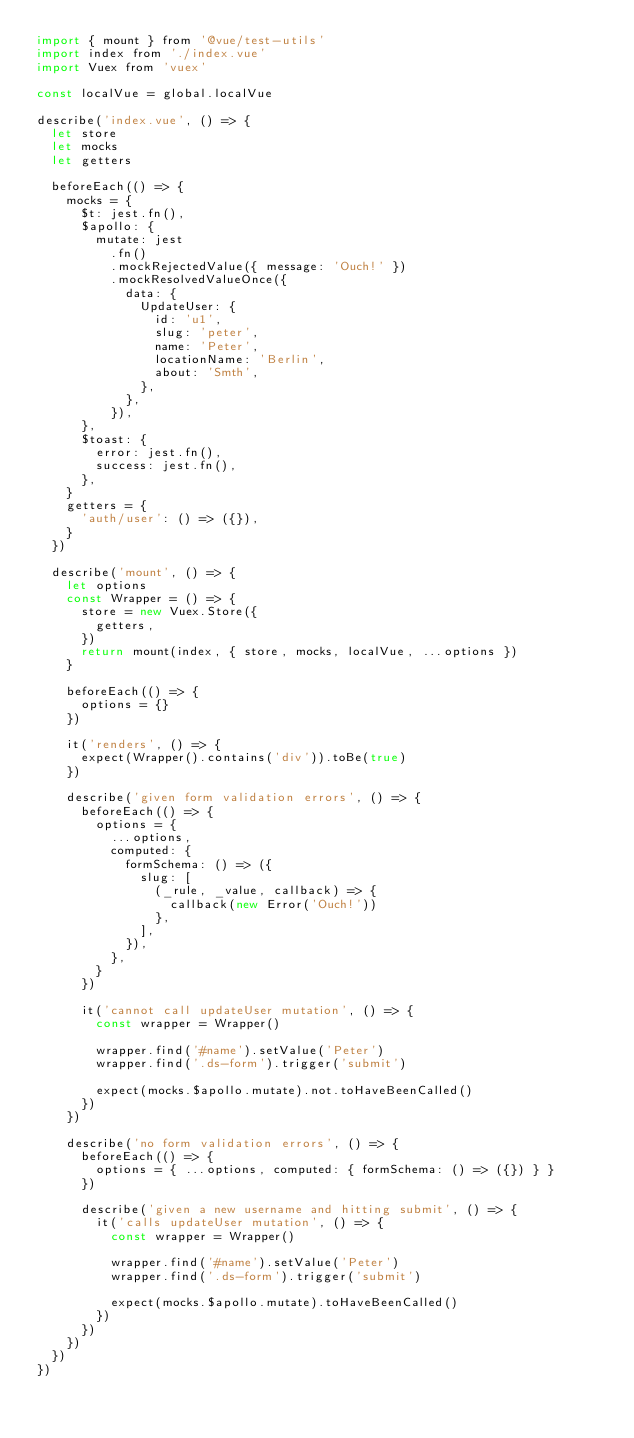<code> <loc_0><loc_0><loc_500><loc_500><_JavaScript_>import { mount } from '@vue/test-utils'
import index from './index.vue'
import Vuex from 'vuex'

const localVue = global.localVue

describe('index.vue', () => {
  let store
  let mocks
  let getters

  beforeEach(() => {
    mocks = {
      $t: jest.fn(),
      $apollo: {
        mutate: jest
          .fn()
          .mockRejectedValue({ message: 'Ouch!' })
          .mockResolvedValueOnce({
            data: {
              UpdateUser: {
                id: 'u1',
                slug: 'peter',
                name: 'Peter',
                locationName: 'Berlin',
                about: 'Smth',
              },
            },
          }),
      },
      $toast: {
        error: jest.fn(),
        success: jest.fn(),
      },
    }
    getters = {
      'auth/user': () => ({}),
    }
  })

  describe('mount', () => {
    let options
    const Wrapper = () => {
      store = new Vuex.Store({
        getters,
      })
      return mount(index, { store, mocks, localVue, ...options })
    }

    beforeEach(() => {
      options = {}
    })

    it('renders', () => {
      expect(Wrapper().contains('div')).toBe(true)
    })

    describe('given form validation errors', () => {
      beforeEach(() => {
        options = {
          ...options,
          computed: {
            formSchema: () => ({
              slug: [
                (_rule, _value, callback) => {
                  callback(new Error('Ouch!'))
                },
              ],
            }),
          },
        }
      })

      it('cannot call updateUser mutation', () => {
        const wrapper = Wrapper()

        wrapper.find('#name').setValue('Peter')
        wrapper.find('.ds-form').trigger('submit')

        expect(mocks.$apollo.mutate).not.toHaveBeenCalled()
      })
    })

    describe('no form validation errors', () => {
      beforeEach(() => {
        options = { ...options, computed: { formSchema: () => ({}) } }
      })

      describe('given a new username and hitting submit', () => {
        it('calls updateUser mutation', () => {
          const wrapper = Wrapper()

          wrapper.find('#name').setValue('Peter')
          wrapper.find('.ds-form').trigger('submit')

          expect(mocks.$apollo.mutate).toHaveBeenCalled()
        })
      })
    })
  })
})
</code> 